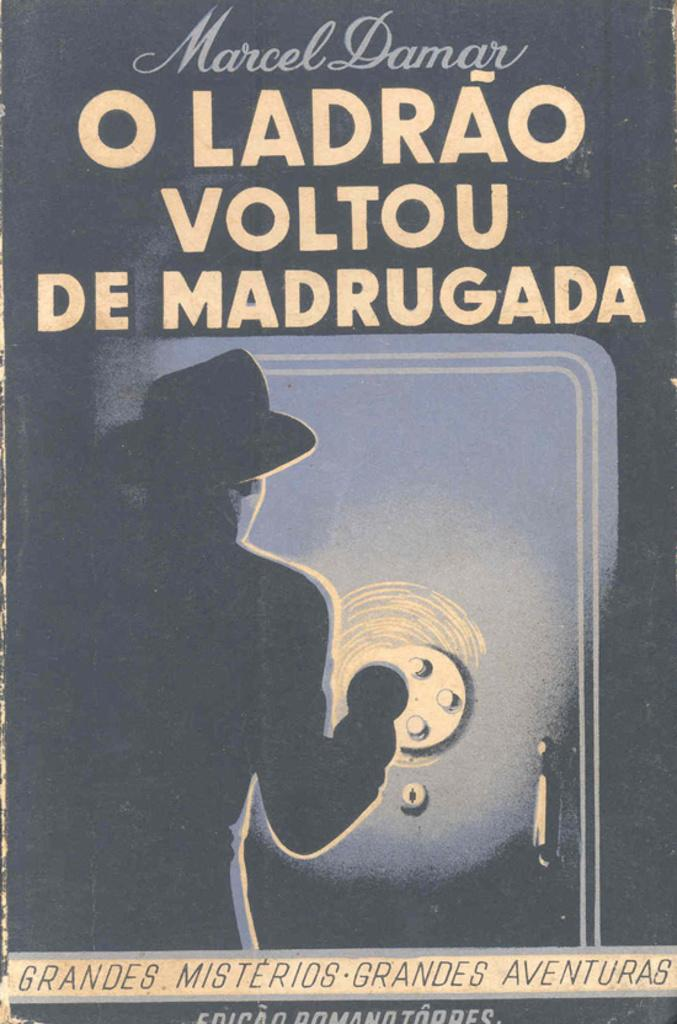<image>
Describe the image concisely. the cover of the book o ladrao voltou de madrugada by marcel damar. 